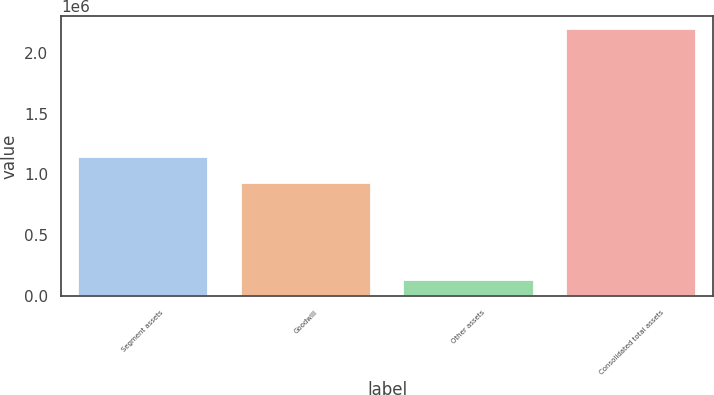Convert chart. <chart><loc_0><loc_0><loc_500><loc_500><bar_chart><fcel>Segment assets<fcel>Goodwill<fcel>Other assets<fcel>Consolidated total assets<nl><fcel>1.13987e+06<fcel>926242<fcel>129282<fcel>2.1954e+06<nl></chart> 